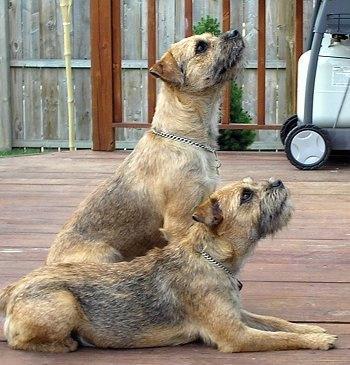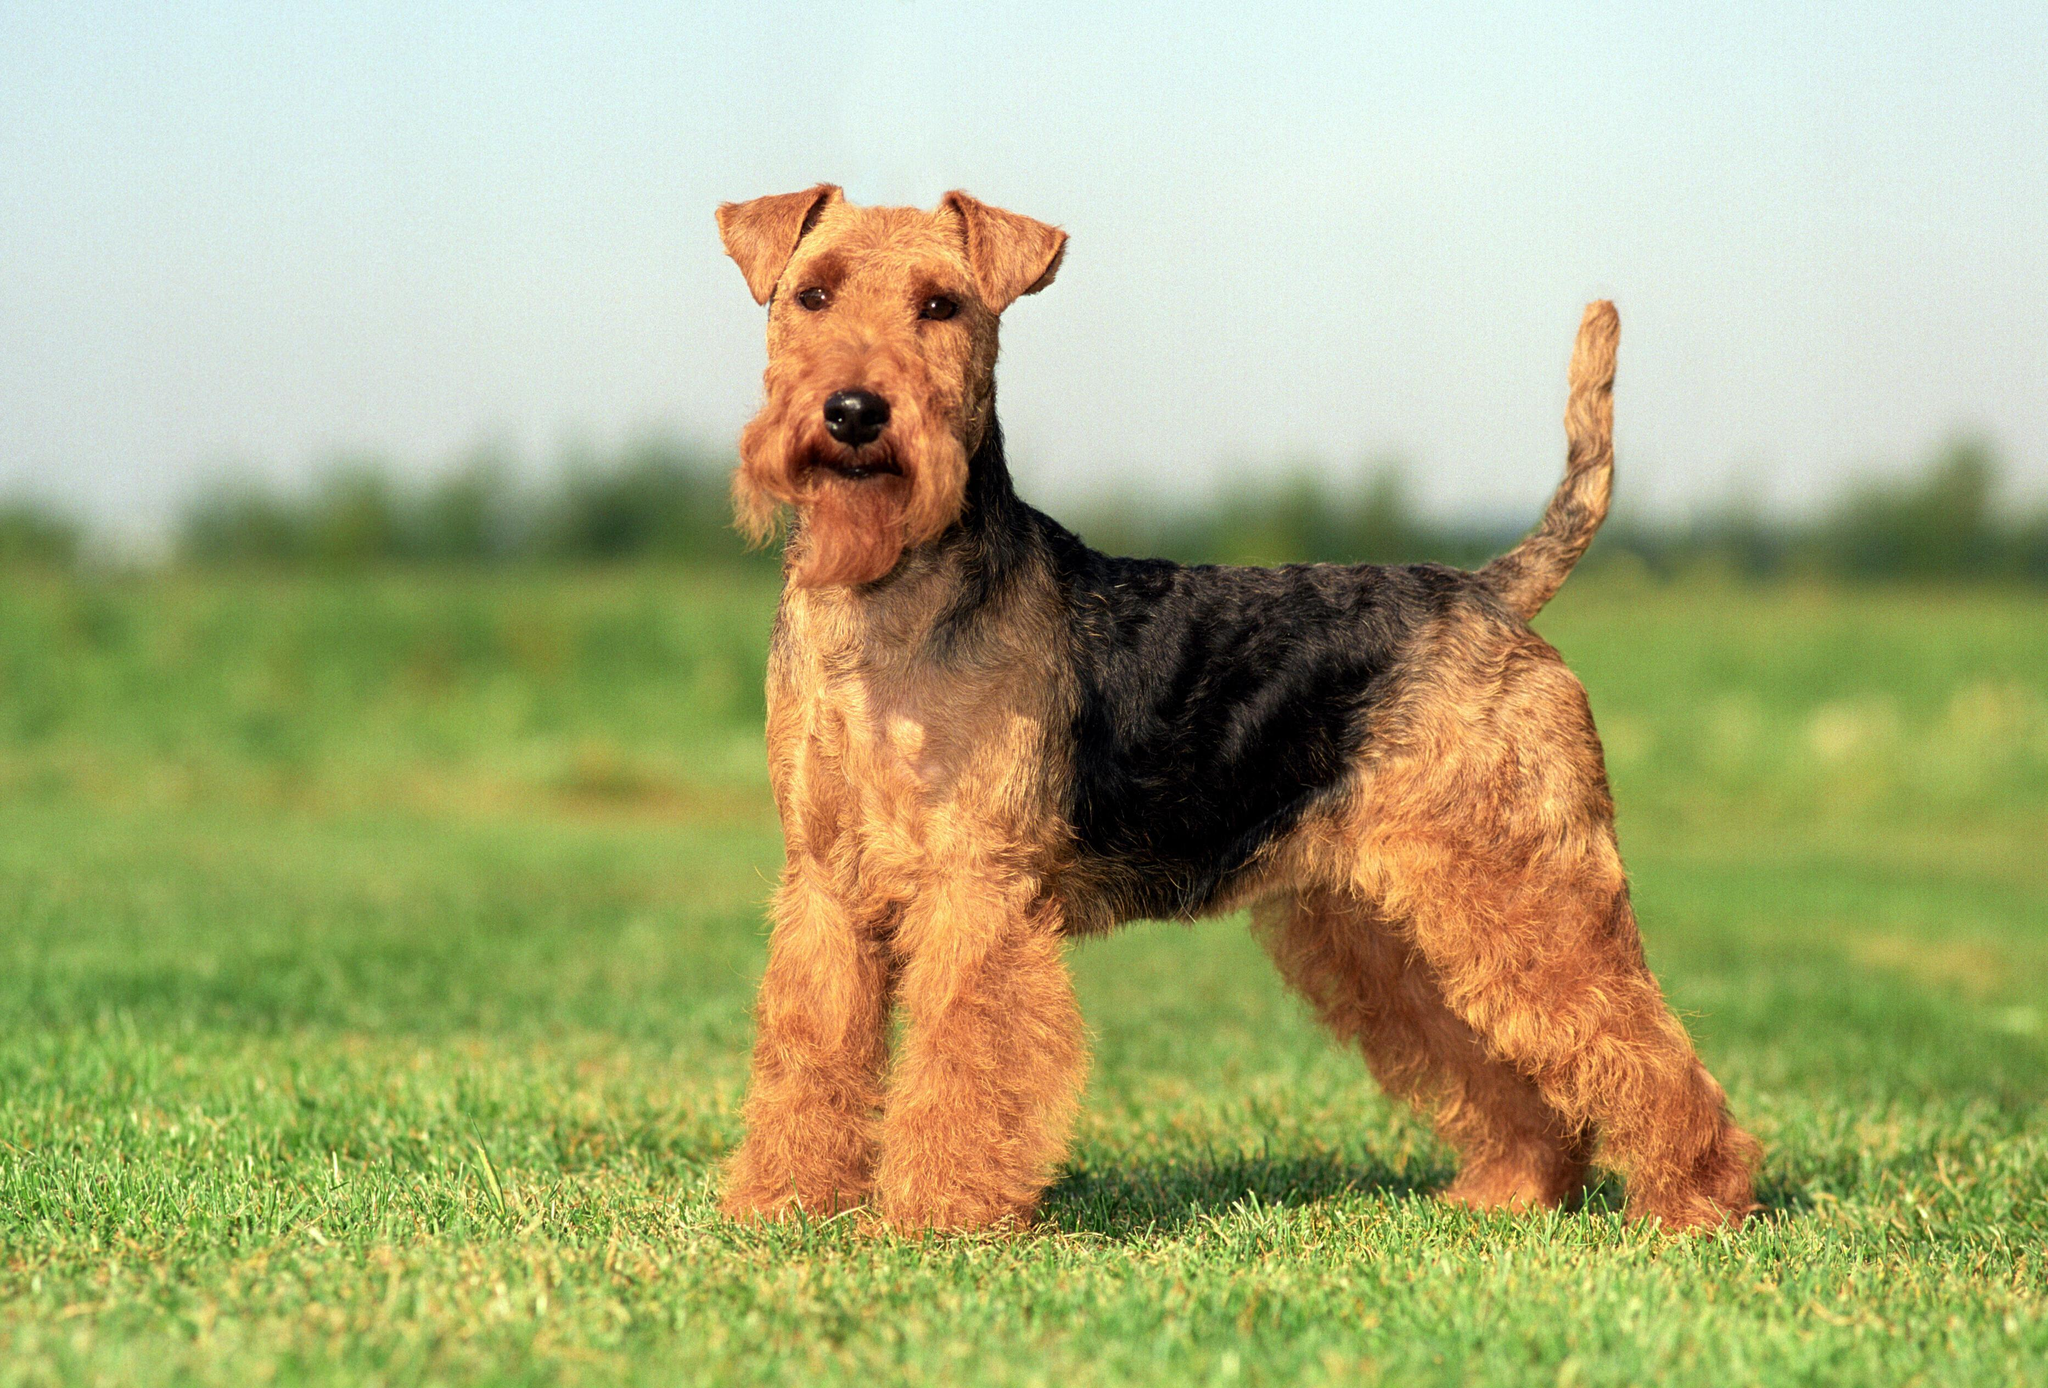The first image is the image on the left, the second image is the image on the right. Given the left and right images, does the statement "One of the dogs is a puppy, and the other is in his middle years; you can visually verify their ages easily." hold true? Answer yes or no. No. 